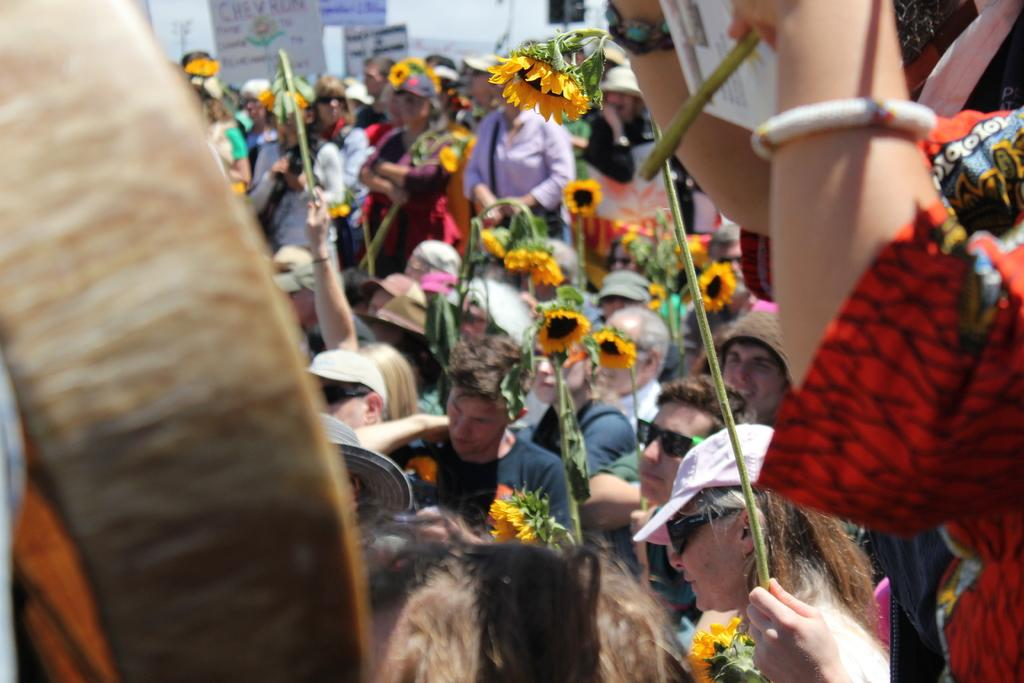What are the people holding in the image? The people are holding sunflower flowers with stems in the image. What else can be seen in the image besides the people and sunflowers? There are boards with text in the image. How many lizards are sitting on the airplane in the image? There are no lizards or airplanes present in the image. 